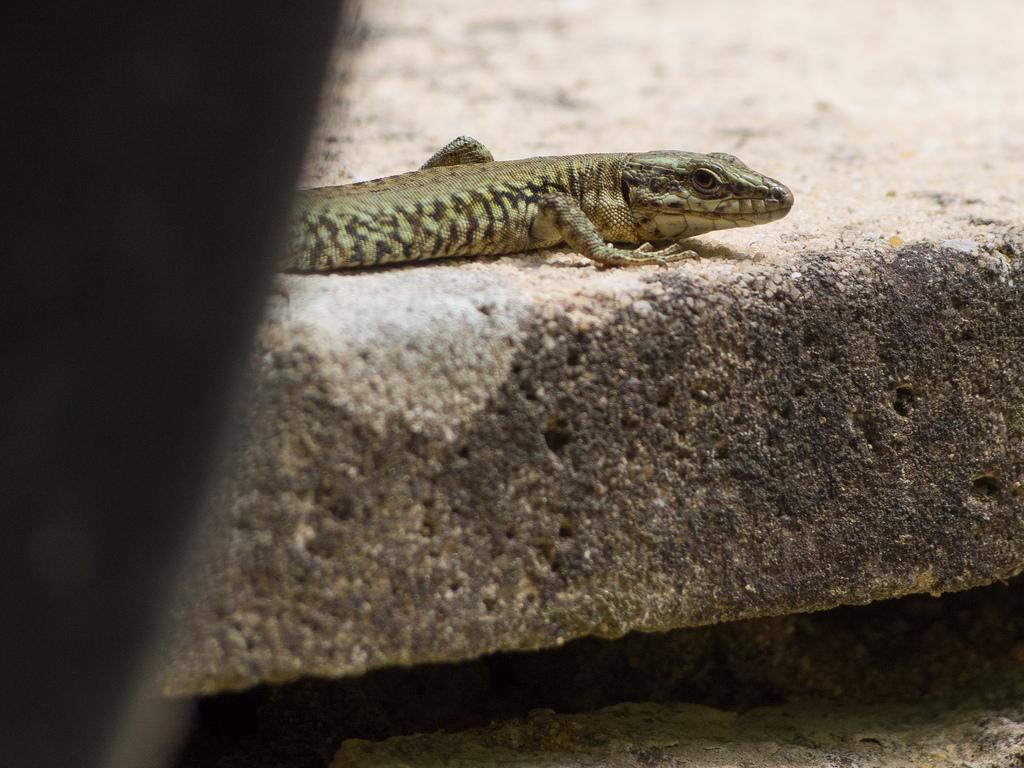What type of animal is in the image? There is a lizard in the image. What colors can be seen on the lizard? The lizard is brown and black in color. Where is the lizard located in the image? The lizard is on a surface. What colors can be seen on the surface? The surface is white and black in color. How would you describe the lighting in the image? The image appears to be dark. How does the tiger show respect to the lizard in the image? There is no tiger present in the image, so it cannot show respect to the lizard. What color is the sky in the image? The sky is not visible in the image, so its color cannot be determined. 